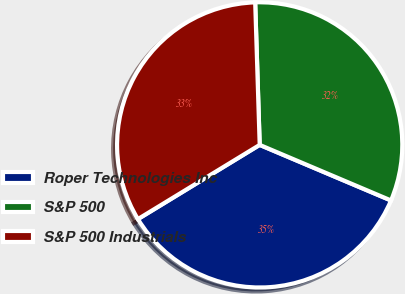<chart> <loc_0><loc_0><loc_500><loc_500><pie_chart><fcel>Roper Technologies Inc<fcel>S&P 500<fcel>S&P 500 Industrials<nl><fcel>34.92%<fcel>31.88%<fcel>33.21%<nl></chart> 